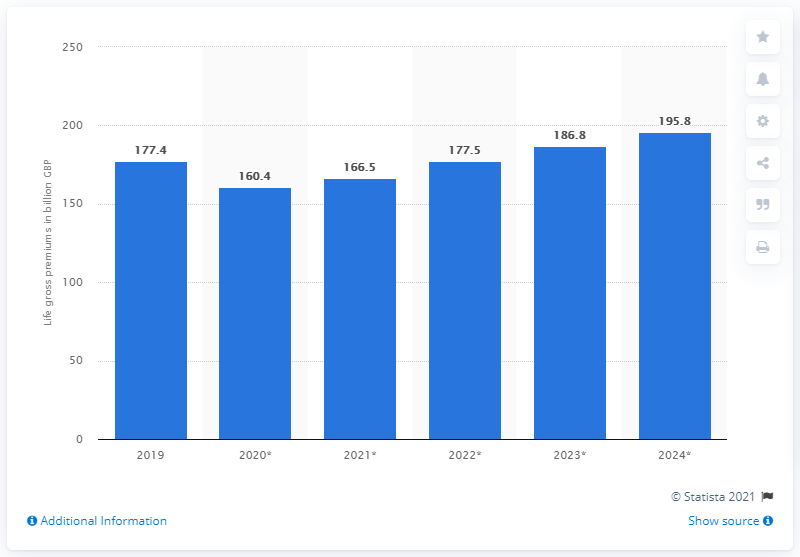Draw attention to some important aspects in this diagram. The estimated value of life insurance gross written premiums in the UK in 2020 is 160.4.. The gross premiums of life insurance in the UK in 2019 were 177.5. 